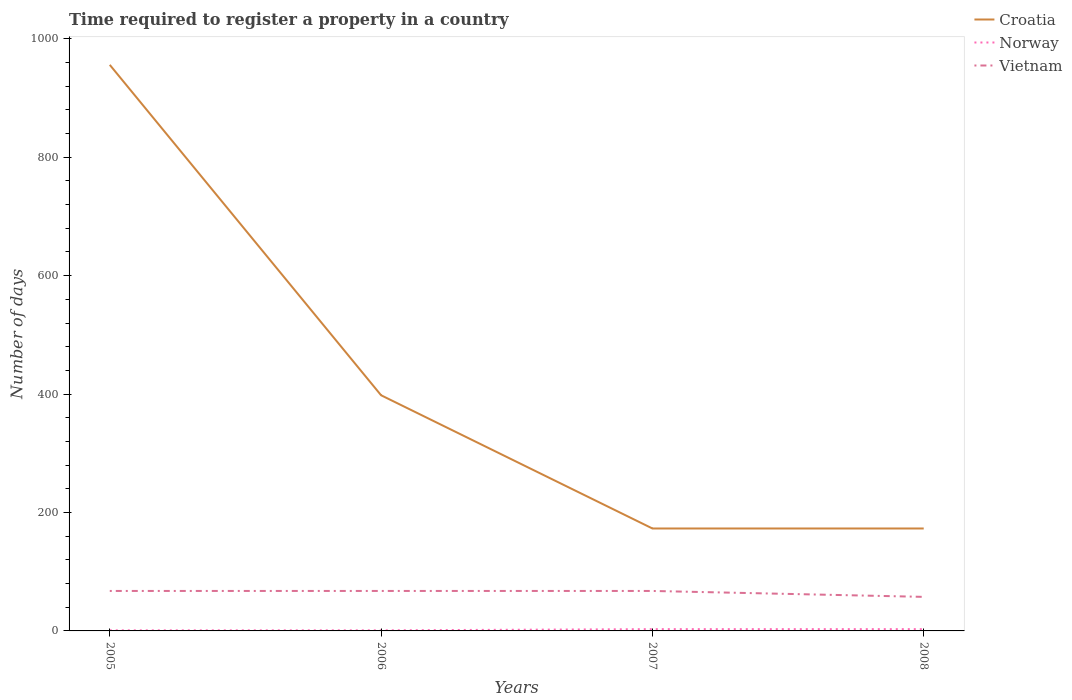Across all years, what is the maximum number of days required to register a property in Croatia?
Your response must be concise. 173. In which year was the number of days required to register a property in Croatia maximum?
Provide a succinct answer. 2007. What is the total number of days required to register a property in Croatia in the graph?
Ensure brevity in your answer.  225. What is the difference between the highest and the second highest number of days required to register a property in Croatia?
Your response must be concise. 783. Is the number of days required to register a property in Norway strictly greater than the number of days required to register a property in Croatia over the years?
Provide a short and direct response. Yes. How many lines are there?
Your answer should be compact. 3. How many years are there in the graph?
Your answer should be compact. 4. Are the values on the major ticks of Y-axis written in scientific E-notation?
Ensure brevity in your answer.  No. Does the graph contain any zero values?
Offer a terse response. No. Where does the legend appear in the graph?
Your response must be concise. Top right. What is the title of the graph?
Your answer should be compact. Time required to register a property in a country. What is the label or title of the X-axis?
Offer a terse response. Years. What is the label or title of the Y-axis?
Offer a terse response. Number of days. What is the Number of days in Croatia in 2005?
Your response must be concise. 956. What is the Number of days in Vietnam in 2005?
Provide a short and direct response. 67.5. What is the Number of days of Croatia in 2006?
Your answer should be very brief. 398. What is the Number of days of Norway in 2006?
Ensure brevity in your answer.  1. What is the Number of days in Vietnam in 2006?
Ensure brevity in your answer.  67.5. What is the Number of days in Croatia in 2007?
Provide a short and direct response. 173. What is the Number of days in Vietnam in 2007?
Your answer should be compact. 67.5. What is the Number of days of Croatia in 2008?
Make the answer very short. 173. What is the Number of days in Vietnam in 2008?
Keep it short and to the point. 57.5. Across all years, what is the maximum Number of days of Croatia?
Make the answer very short. 956. Across all years, what is the maximum Number of days in Vietnam?
Offer a terse response. 67.5. Across all years, what is the minimum Number of days of Croatia?
Your response must be concise. 173. Across all years, what is the minimum Number of days of Vietnam?
Offer a very short reply. 57.5. What is the total Number of days of Croatia in the graph?
Offer a very short reply. 1700. What is the total Number of days of Vietnam in the graph?
Your answer should be compact. 260. What is the difference between the Number of days in Croatia in 2005 and that in 2006?
Give a very brief answer. 558. What is the difference between the Number of days in Norway in 2005 and that in 2006?
Ensure brevity in your answer.  0. What is the difference between the Number of days of Croatia in 2005 and that in 2007?
Ensure brevity in your answer.  783. What is the difference between the Number of days of Croatia in 2005 and that in 2008?
Your answer should be compact. 783. What is the difference between the Number of days of Norway in 2005 and that in 2008?
Keep it short and to the point. -2. What is the difference between the Number of days of Croatia in 2006 and that in 2007?
Your answer should be compact. 225. What is the difference between the Number of days of Norway in 2006 and that in 2007?
Provide a short and direct response. -2. What is the difference between the Number of days in Croatia in 2006 and that in 2008?
Make the answer very short. 225. What is the difference between the Number of days of Norway in 2006 and that in 2008?
Your answer should be compact. -2. What is the difference between the Number of days in Croatia in 2007 and that in 2008?
Keep it short and to the point. 0. What is the difference between the Number of days of Vietnam in 2007 and that in 2008?
Provide a short and direct response. 10. What is the difference between the Number of days of Croatia in 2005 and the Number of days of Norway in 2006?
Offer a terse response. 955. What is the difference between the Number of days in Croatia in 2005 and the Number of days in Vietnam in 2006?
Make the answer very short. 888.5. What is the difference between the Number of days in Norway in 2005 and the Number of days in Vietnam in 2006?
Provide a succinct answer. -66.5. What is the difference between the Number of days in Croatia in 2005 and the Number of days in Norway in 2007?
Your answer should be compact. 953. What is the difference between the Number of days of Croatia in 2005 and the Number of days of Vietnam in 2007?
Ensure brevity in your answer.  888.5. What is the difference between the Number of days in Norway in 2005 and the Number of days in Vietnam in 2007?
Your response must be concise. -66.5. What is the difference between the Number of days of Croatia in 2005 and the Number of days of Norway in 2008?
Ensure brevity in your answer.  953. What is the difference between the Number of days in Croatia in 2005 and the Number of days in Vietnam in 2008?
Keep it short and to the point. 898.5. What is the difference between the Number of days of Norway in 2005 and the Number of days of Vietnam in 2008?
Provide a succinct answer. -56.5. What is the difference between the Number of days of Croatia in 2006 and the Number of days of Norway in 2007?
Provide a succinct answer. 395. What is the difference between the Number of days in Croatia in 2006 and the Number of days in Vietnam in 2007?
Provide a succinct answer. 330.5. What is the difference between the Number of days of Norway in 2006 and the Number of days of Vietnam in 2007?
Your answer should be very brief. -66.5. What is the difference between the Number of days of Croatia in 2006 and the Number of days of Norway in 2008?
Make the answer very short. 395. What is the difference between the Number of days in Croatia in 2006 and the Number of days in Vietnam in 2008?
Offer a very short reply. 340.5. What is the difference between the Number of days in Norway in 2006 and the Number of days in Vietnam in 2008?
Keep it short and to the point. -56.5. What is the difference between the Number of days in Croatia in 2007 and the Number of days in Norway in 2008?
Make the answer very short. 170. What is the difference between the Number of days of Croatia in 2007 and the Number of days of Vietnam in 2008?
Keep it short and to the point. 115.5. What is the difference between the Number of days of Norway in 2007 and the Number of days of Vietnam in 2008?
Provide a succinct answer. -54.5. What is the average Number of days in Croatia per year?
Provide a succinct answer. 425. What is the average Number of days in Norway per year?
Your answer should be very brief. 2. In the year 2005, what is the difference between the Number of days in Croatia and Number of days in Norway?
Ensure brevity in your answer.  955. In the year 2005, what is the difference between the Number of days of Croatia and Number of days of Vietnam?
Your answer should be compact. 888.5. In the year 2005, what is the difference between the Number of days of Norway and Number of days of Vietnam?
Give a very brief answer. -66.5. In the year 2006, what is the difference between the Number of days in Croatia and Number of days in Norway?
Your answer should be compact. 397. In the year 2006, what is the difference between the Number of days in Croatia and Number of days in Vietnam?
Your answer should be very brief. 330.5. In the year 2006, what is the difference between the Number of days of Norway and Number of days of Vietnam?
Offer a terse response. -66.5. In the year 2007, what is the difference between the Number of days of Croatia and Number of days of Norway?
Offer a very short reply. 170. In the year 2007, what is the difference between the Number of days in Croatia and Number of days in Vietnam?
Keep it short and to the point. 105.5. In the year 2007, what is the difference between the Number of days of Norway and Number of days of Vietnam?
Provide a short and direct response. -64.5. In the year 2008, what is the difference between the Number of days in Croatia and Number of days in Norway?
Provide a short and direct response. 170. In the year 2008, what is the difference between the Number of days of Croatia and Number of days of Vietnam?
Provide a short and direct response. 115.5. In the year 2008, what is the difference between the Number of days in Norway and Number of days in Vietnam?
Give a very brief answer. -54.5. What is the ratio of the Number of days of Croatia in 2005 to that in 2006?
Provide a short and direct response. 2.4. What is the ratio of the Number of days of Norway in 2005 to that in 2006?
Your answer should be compact. 1. What is the ratio of the Number of days in Croatia in 2005 to that in 2007?
Your response must be concise. 5.53. What is the ratio of the Number of days of Norway in 2005 to that in 2007?
Provide a short and direct response. 0.33. What is the ratio of the Number of days in Vietnam in 2005 to that in 2007?
Give a very brief answer. 1. What is the ratio of the Number of days in Croatia in 2005 to that in 2008?
Your response must be concise. 5.53. What is the ratio of the Number of days in Norway in 2005 to that in 2008?
Your response must be concise. 0.33. What is the ratio of the Number of days of Vietnam in 2005 to that in 2008?
Your response must be concise. 1.17. What is the ratio of the Number of days of Croatia in 2006 to that in 2007?
Your answer should be very brief. 2.3. What is the ratio of the Number of days in Norway in 2006 to that in 2007?
Your answer should be compact. 0.33. What is the ratio of the Number of days in Vietnam in 2006 to that in 2007?
Your answer should be compact. 1. What is the ratio of the Number of days in Croatia in 2006 to that in 2008?
Provide a succinct answer. 2.3. What is the ratio of the Number of days in Norway in 2006 to that in 2008?
Ensure brevity in your answer.  0.33. What is the ratio of the Number of days of Vietnam in 2006 to that in 2008?
Your answer should be compact. 1.17. What is the ratio of the Number of days of Vietnam in 2007 to that in 2008?
Your response must be concise. 1.17. What is the difference between the highest and the second highest Number of days in Croatia?
Keep it short and to the point. 558. What is the difference between the highest and the second highest Number of days of Norway?
Your answer should be compact. 0. What is the difference between the highest and the second highest Number of days in Vietnam?
Offer a very short reply. 0. What is the difference between the highest and the lowest Number of days in Croatia?
Your answer should be compact. 783. 